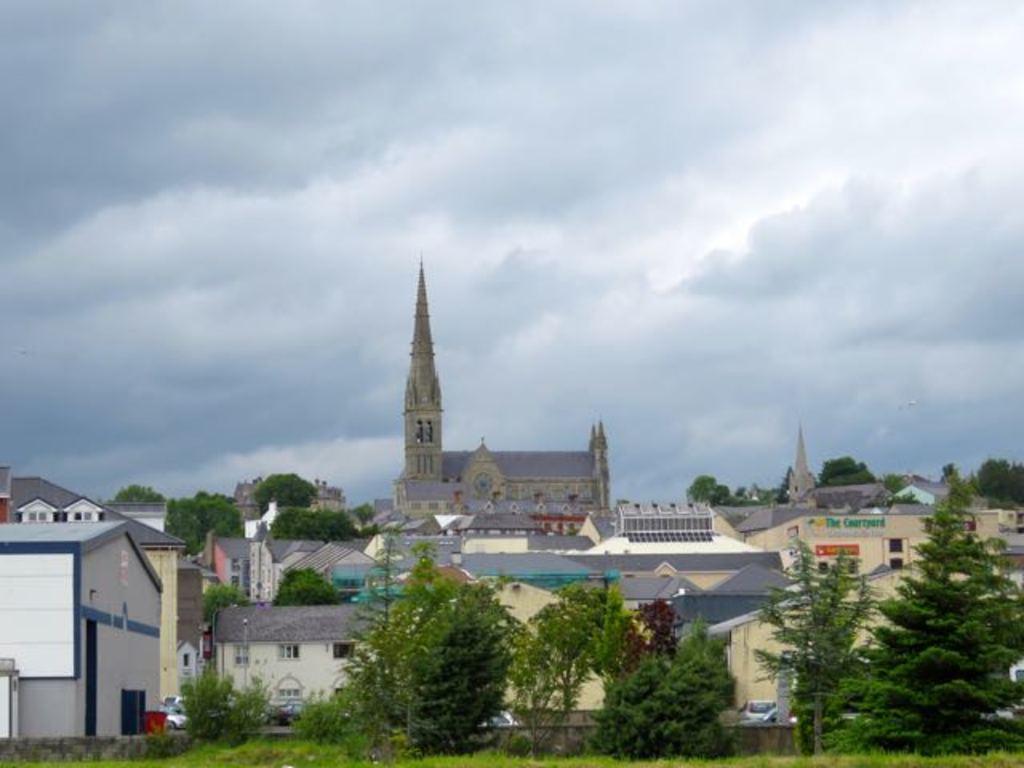Please provide a concise description of this image. In this image there are some buildings, houses, trees, plants, vehicles and at the bottom there is grass. And at the top of the image there is sky. 